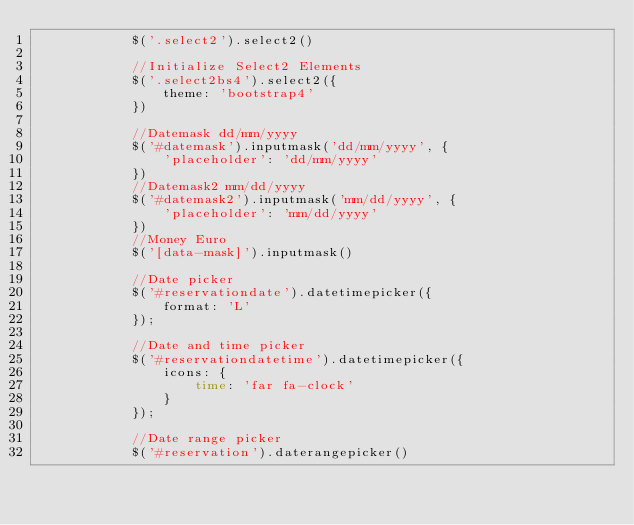Convert code to text. <code><loc_0><loc_0><loc_500><loc_500><_PHP_>            $('.select2').select2()

            //Initialize Select2 Elements
            $('.select2bs4').select2({
                theme: 'bootstrap4'
            })

            //Datemask dd/mm/yyyy
            $('#datemask').inputmask('dd/mm/yyyy', {
                'placeholder': 'dd/mm/yyyy'
            })
            //Datemask2 mm/dd/yyyy
            $('#datemask2').inputmask('mm/dd/yyyy', {
                'placeholder': 'mm/dd/yyyy'
            })
            //Money Euro
            $('[data-mask]').inputmask()

            //Date picker
            $('#reservationdate').datetimepicker({
                format: 'L'
            });

            //Date and time picker
            $('#reservationdatetime').datetimepicker({
                icons: {
                    time: 'far fa-clock'
                }
            });

            //Date range picker
            $('#reservation').daterangepicker()</code> 